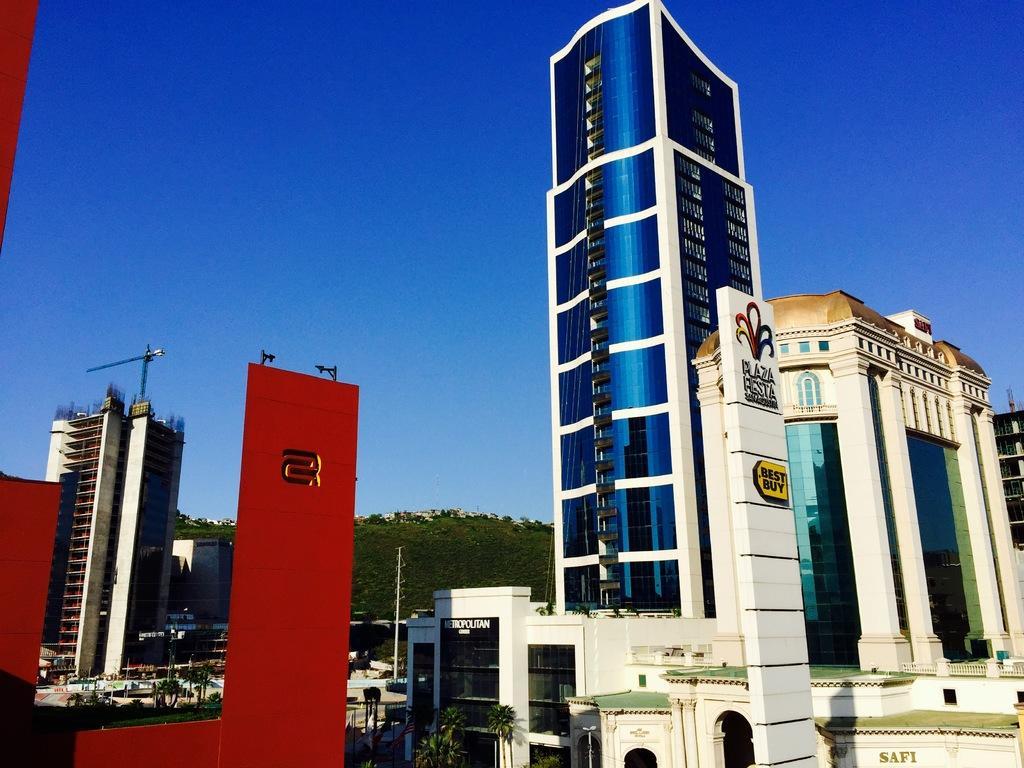How would you summarize this image in a sentence or two? This is an outside view. At the bottom there are many buildings and trees. On the left side there is a crane. At the top of the image I can see the sky in blue color. 